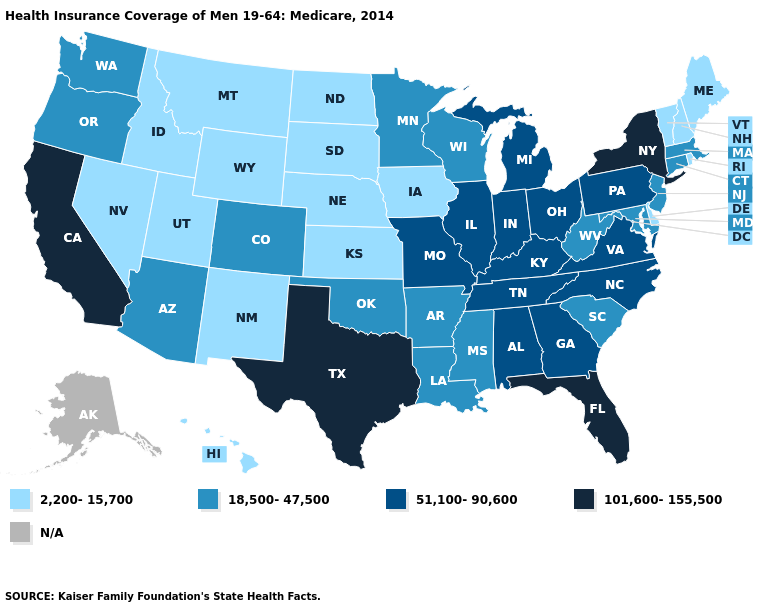Among the states that border Connecticut , which have the highest value?
Give a very brief answer. New York. What is the lowest value in the South?
Give a very brief answer. 2,200-15,700. Name the states that have a value in the range 2,200-15,700?
Short answer required. Delaware, Hawaii, Idaho, Iowa, Kansas, Maine, Montana, Nebraska, Nevada, New Hampshire, New Mexico, North Dakota, Rhode Island, South Dakota, Utah, Vermont, Wyoming. Among the states that border Arizona , does California have the lowest value?
Answer briefly. No. Among the states that border Michigan , which have the highest value?
Be succinct. Indiana, Ohio. Name the states that have a value in the range 51,100-90,600?
Concise answer only. Alabama, Georgia, Illinois, Indiana, Kentucky, Michigan, Missouri, North Carolina, Ohio, Pennsylvania, Tennessee, Virginia. What is the value of New Hampshire?
Quick response, please. 2,200-15,700. How many symbols are there in the legend?
Quick response, please. 5. Which states have the lowest value in the MidWest?
Give a very brief answer. Iowa, Kansas, Nebraska, North Dakota, South Dakota. Which states hav the highest value in the South?
Give a very brief answer. Florida, Texas. What is the value of New Jersey?
Short answer required. 18,500-47,500. Name the states that have a value in the range 18,500-47,500?
Be succinct. Arizona, Arkansas, Colorado, Connecticut, Louisiana, Maryland, Massachusetts, Minnesota, Mississippi, New Jersey, Oklahoma, Oregon, South Carolina, Washington, West Virginia, Wisconsin. What is the value of Montana?
Concise answer only. 2,200-15,700. 